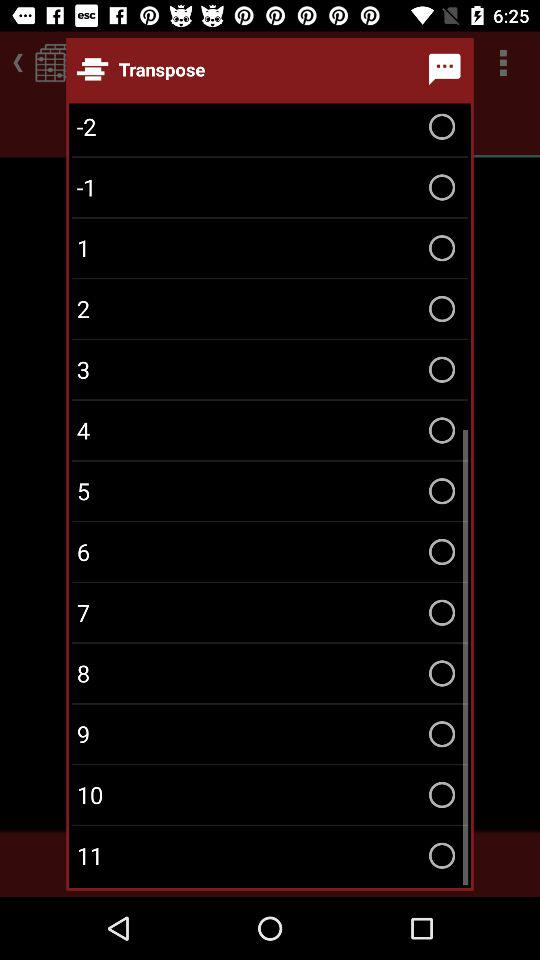Is "7" selected or not? "7" is not selected. 